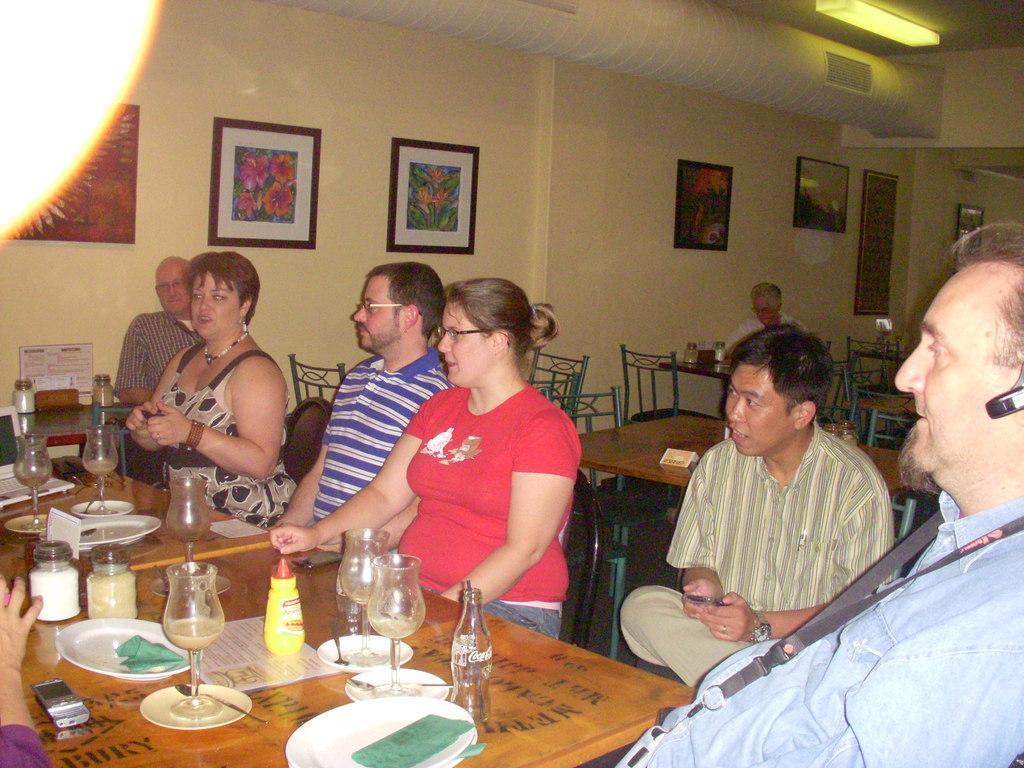How would you summarize this image in a sentence or two? In this image I can see number of people are sitting on chairs. Here on this table I can see few plates, glasses and a bottle. On this wall I can see few frames. 